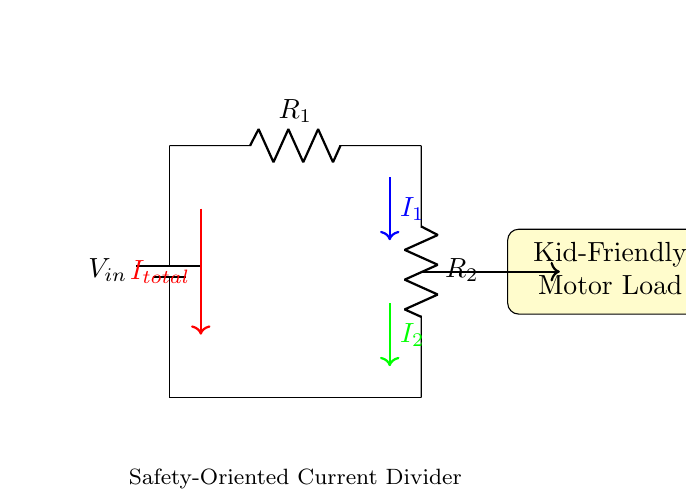What is the input voltage of the circuit? The input voltage is denoted as V_in in the circuit, which represents the potential difference supplied by the battery.
Answer: V_in What components are present in the circuit? The circuit contains a battery, two resistors labeled R_1 and R_2, and a motor load, identified as the kid-friendly motor load.
Answer: Battery, R_1, R_2, motor load What are the current paths in this circuit? The current paths can be traced from the battery to the load, splitting into two branches through resistors R_1 and R_2, each represented as I_1 and I_2 respectively.
Answer: I_1, I_2 How does the current divide between R_1 and R_2? The current divides based on the resistance values; the total current I_total is split into I_1 through R_1 and I_2 through R_2, following the current divider rule, which states that the current is inversely proportional to the resistance.
Answer: Based on resistance values What does the red arrow represent in the circuit? The red arrow indicates the total current I_total flowing from the battery into the circuit, which then splits into two currents through the resistors.
Answer: Total current What is the purpose of this circuit? The purpose of this circuit is to safely provide a low-voltage power source to drive a kid-friendly DIY electric motor, demonstrating the principles of a current divider while ensuring safety for young users.
Answer: To power a kid-friendly electric motor 